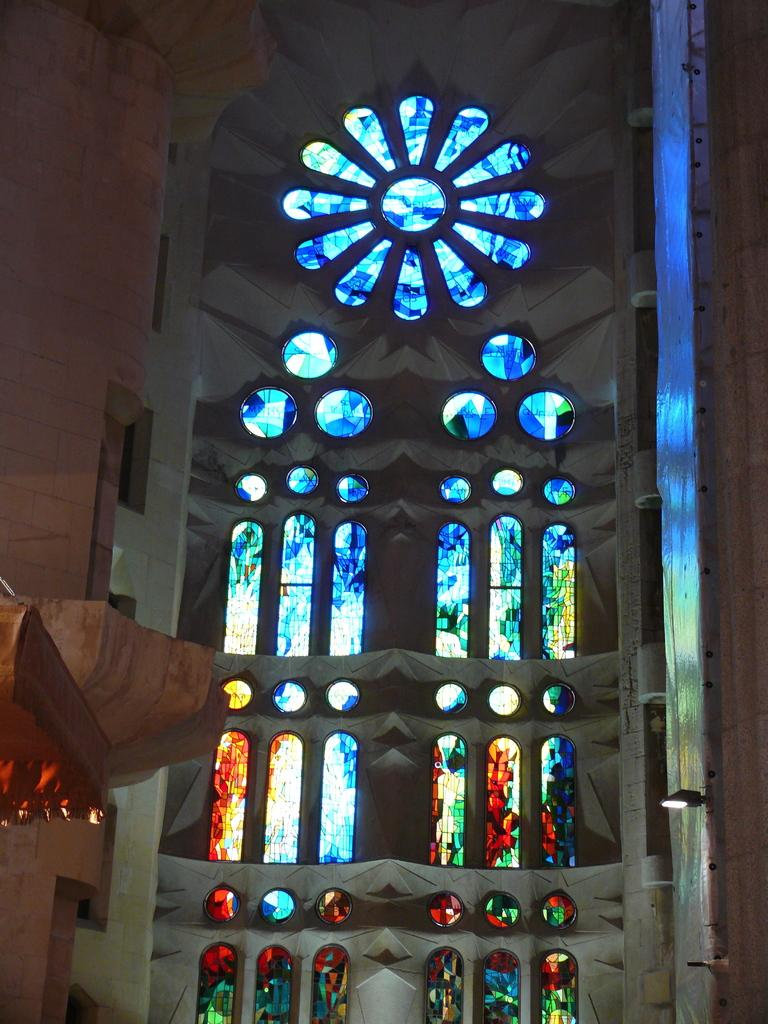What type of building is depicted in the image? The image is an inside view of a church. What can be seen on the walls of the church? There is a glass painting in the church. Where is the light source located in the image? There is a light on the right side of the image. What architectural feature is present on the left side of the image? There are pillars on the left side of the image. What type of haircut does the priest have in the image? There is no priest or hair visible in the image; it is an inside view of a church with a glass painting, light, and pillars. 